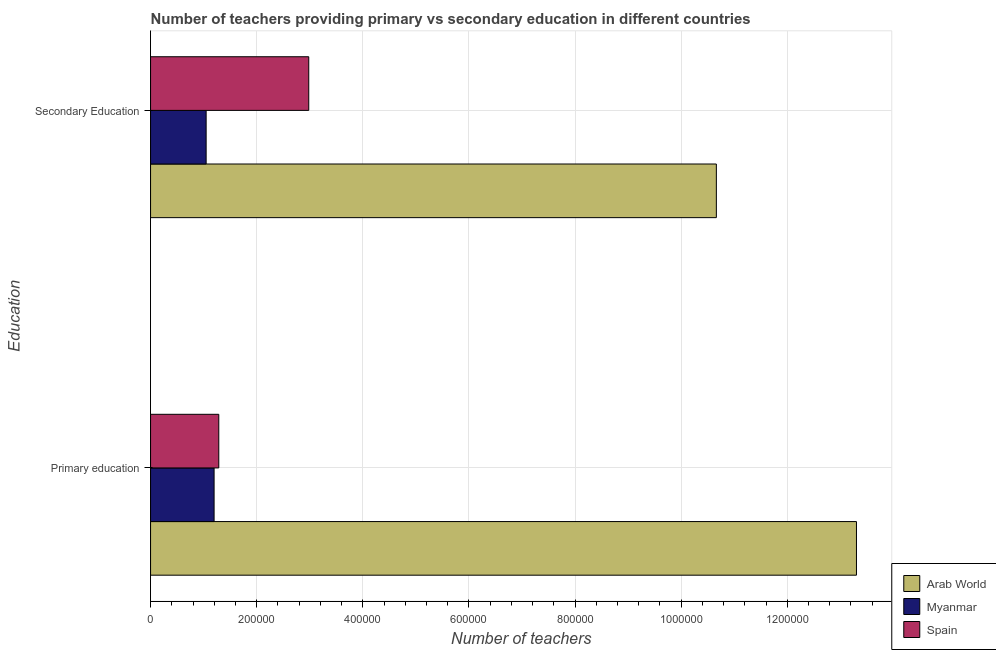How many different coloured bars are there?
Your response must be concise. 3. How many groups of bars are there?
Keep it short and to the point. 2. Are the number of bars per tick equal to the number of legend labels?
Your answer should be very brief. Yes. Are the number of bars on each tick of the Y-axis equal?
Make the answer very short. Yes. How many bars are there on the 1st tick from the top?
Provide a succinct answer. 3. How many bars are there on the 2nd tick from the bottom?
Keep it short and to the point. 3. What is the label of the 1st group of bars from the top?
Your answer should be very brief. Secondary Education. What is the number of primary teachers in Arab World?
Give a very brief answer. 1.33e+06. Across all countries, what is the maximum number of primary teachers?
Make the answer very short. 1.33e+06. Across all countries, what is the minimum number of primary teachers?
Give a very brief answer. 1.20e+05. In which country was the number of secondary teachers maximum?
Offer a very short reply. Arab World. In which country was the number of primary teachers minimum?
Your response must be concise. Myanmar. What is the total number of secondary teachers in the graph?
Give a very brief answer. 1.47e+06. What is the difference between the number of primary teachers in Arab World and that in Myanmar?
Give a very brief answer. 1.21e+06. What is the difference between the number of primary teachers in Spain and the number of secondary teachers in Myanmar?
Your response must be concise. 2.38e+04. What is the average number of primary teachers per country?
Your response must be concise. 5.26e+05. What is the difference between the number of primary teachers and number of secondary teachers in Myanmar?
Your answer should be compact. 1.50e+04. What is the ratio of the number of primary teachers in Arab World to that in Spain?
Your answer should be compact. 10.35. In how many countries, is the number of primary teachers greater than the average number of primary teachers taken over all countries?
Provide a short and direct response. 1. What does the 2nd bar from the top in Secondary Education represents?
Offer a very short reply. Myanmar. Are the values on the major ticks of X-axis written in scientific E-notation?
Make the answer very short. No. Does the graph contain any zero values?
Provide a short and direct response. No. How many legend labels are there?
Ensure brevity in your answer.  3. How are the legend labels stacked?
Ensure brevity in your answer.  Vertical. What is the title of the graph?
Your response must be concise. Number of teachers providing primary vs secondary education in different countries. What is the label or title of the X-axis?
Offer a very short reply. Number of teachers. What is the label or title of the Y-axis?
Your answer should be very brief. Education. What is the Number of teachers in Arab World in Primary education?
Give a very brief answer. 1.33e+06. What is the Number of teachers in Myanmar in Primary education?
Offer a terse response. 1.20e+05. What is the Number of teachers of Spain in Primary education?
Your answer should be very brief. 1.29e+05. What is the Number of teachers in Arab World in Secondary Education?
Give a very brief answer. 1.07e+06. What is the Number of teachers of Myanmar in Secondary Education?
Your answer should be very brief. 1.05e+05. What is the Number of teachers of Spain in Secondary Education?
Make the answer very short. 2.98e+05. Across all Education, what is the maximum Number of teachers of Arab World?
Your answer should be compact. 1.33e+06. Across all Education, what is the maximum Number of teachers in Myanmar?
Make the answer very short. 1.20e+05. Across all Education, what is the maximum Number of teachers of Spain?
Keep it short and to the point. 2.98e+05. Across all Education, what is the minimum Number of teachers of Arab World?
Your response must be concise. 1.07e+06. Across all Education, what is the minimum Number of teachers in Myanmar?
Ensure brevity in your answer.  1.05e+05. Across all Education, what is the minimum Number of teachers of Spain?
Your response must be concise. 1.29e+05. What is the total Number of teachers of Arab World in the graph?
Offer a very short reply. 2.40e+06. What is the total Number of teachers in Myanmar in the graph?
Make the answer very short. 2.24e+05. What is the total Number of teachers in Spain in the graph?
Offer a very short reply. 4.27e+05. What is the difference between the Number of teachers in Arab World in Primary education and that in Secondary Education?
Ensure brevity in your answer.  2.64e+05. What is the difference between the Number of teachers in Myanmar in Primary education and that in Secondary Education?
Offer a terse response. 1.50e+04. What is the difference between the Number of teachers of Spain in Primary education and that in Secondary Education?
Ensure brevity in your answer.  -1.70e+05. What is the difference between the Number of teachers in Arab World in Primary education and the Number of teachers in Myanmar in Secondary Education?
Provide a short and direct response. 1.23e+06. What is the difference between the Number of teachers of Arab World in Primary education and the Number of teachers of Spain in Secondary Education?
Offer a terse response. 1.03e+06. What is the difference between the Number of teachers in Myanmar in Primary education and the Number of teachers in Spain in Secondary Education?
Your answer should be compact. -1.78e+05. What is the average Number of teachers of Arab World per Education?
Keep it short and to the point. 1.20e+06. What is the average Number of teachers of Myanmar per Education?
Your answer should be compact. 1.12e+05. What is the average Number of teachers of Spain per Education?
Your response must be concise. 2.13e+05. What is the difference between the Number of teachers of Arab World and Number of teachers of Myanmar in Primary education?
Keep it short and to the point. 1.21e+06. What is the difference between the Number of teachers in Arab World and Number of teachers in Spain in Primary education?
Make the answer very short. 1.20e+06. What is the difference between the Number of teachers of Myanmar and Number of teachers of Spain in Primary education?
Make the answer very short. -8834. What is the difference between the Number of teachers in Arab World and Number of teachers in Myanmar in Secondary Education?
Your answer should be very brief. 9.62e+05. What is the difference between the Number of teachers of Arab World and Number of teachers of Spain in Secondary Education?
Give a very brief answer. 7.68e+05. What is the difference between the Number of teachers of Myanmar and Number of teachers of Spain in Secondary Education?
Provide a short and direct response. -1.93e+05. What is the ratio of the Number of teachers in Arab World in Primary education to that in Secondary Education?
Keep it short and to the point. 1.25. What is the ratio of the Number of teachers in Myanmar in Primary education to that in Secondary Education?
Offer a very short reply. 1.14. What is the ratio of the Number of teachers in Spain in Primary education to that in Secondary Education?
Offer a very short reply. 0.43. What is the difference between the highest and the second highest Number of teachers of Arab World?
Keep it short and to the point. 2.64e+05. What is the difference between the highest and the second highest Number of teachers of Myanmar?
Offer a very short reply. 1.50e+04. What is the difference between the highest and the second highest Number of teachers of Spain?
Provide a succinct answer. 1.70e+05. What is the difference between the highest and the lowest Number of teachers in Arab World?
Provide a succinct answer. 2.64e+05. What is the difference between the highest and the lowest Number of teachers of Myanmar?
Give a very brief answer. 1.50e+04. What is the difference between the highest and the lowest Number of teachers of Spain?
Make the answer very short. 1.70e+05. 